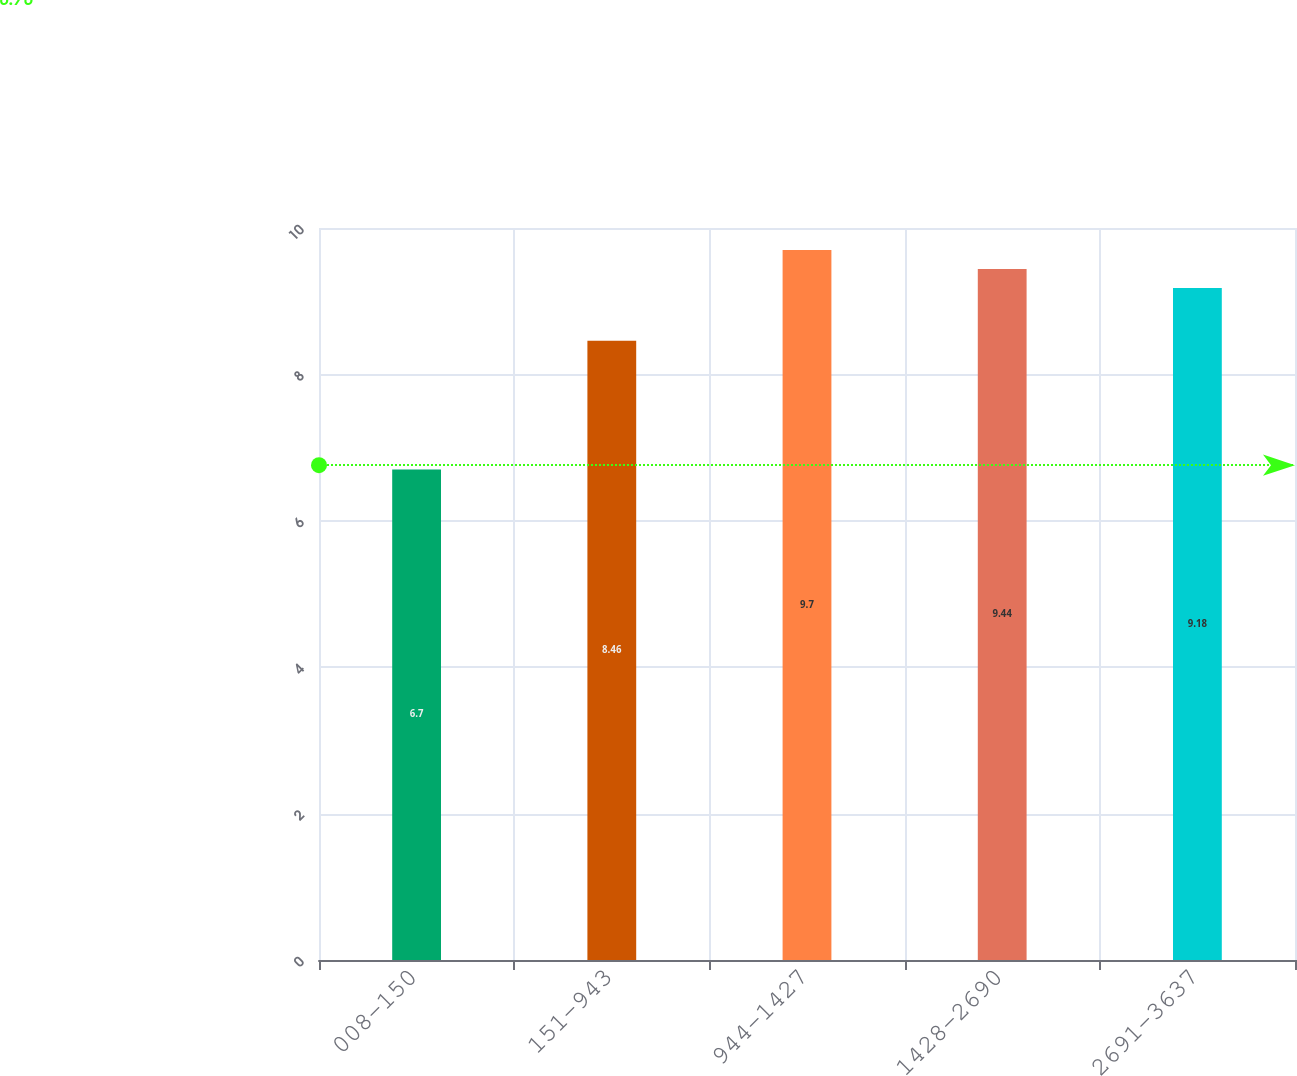Convert chart to OTSL. <chart><loc_0><loc_0><loc_500><loc_500><bar_chart><fcel>008-150<fcel>151-943<fcel>944-1427<fcel>1428-2690<fcel>2691-3637<nl><fcel>6.7<fcel>8.46<fcel>9.7<fcel>9.44<fcel>9.18<nl></chart> 